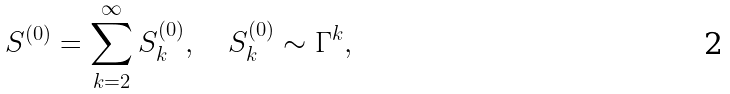<formula> <loc_0><loc_0><loc_500><loc_500>S ^ { ( 0 ) } = \sum _ { k = 2 } ^ { \infty } S _ { k } ^ { ( 0 ) } , \quad S _ { k } ^ { ( 0 ) } \sim \Gamma ^ { k } ,</formula> 